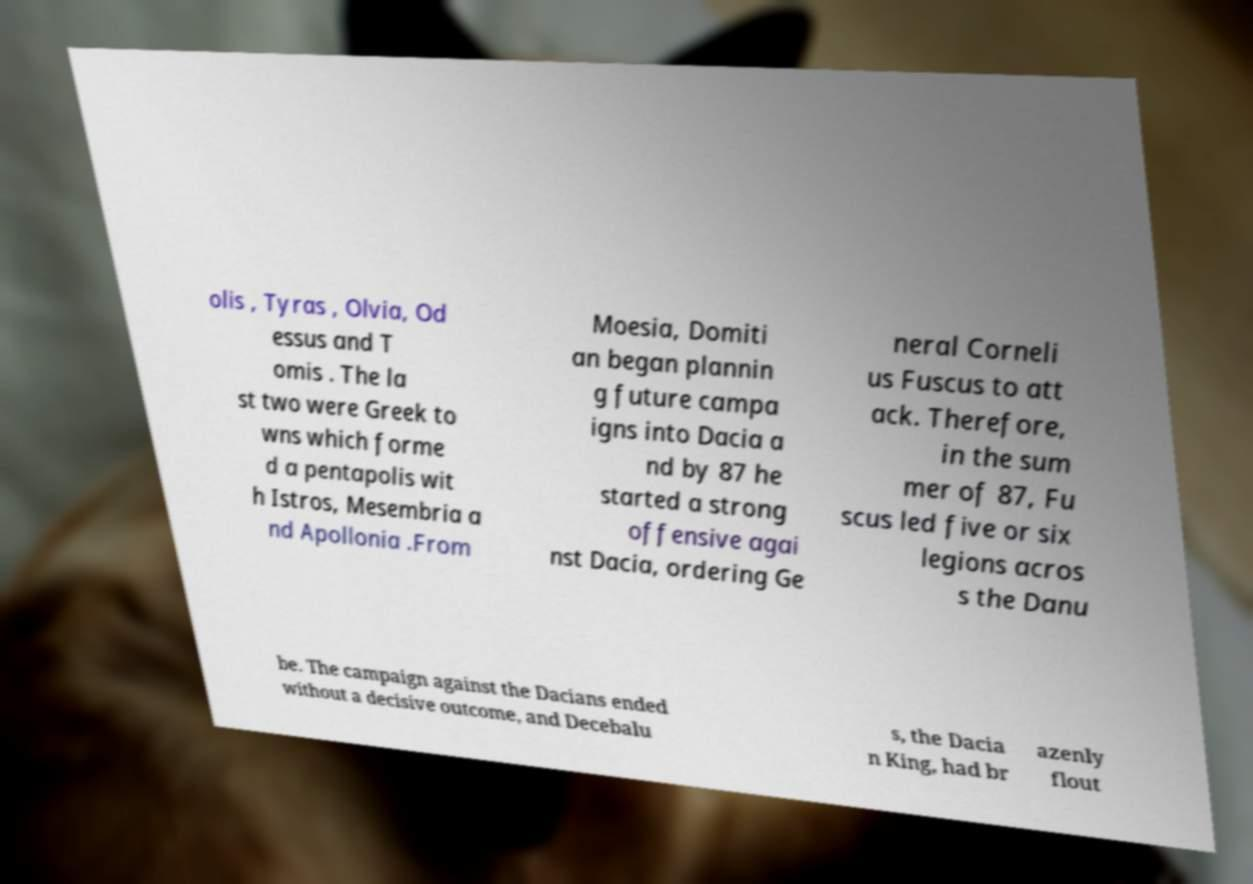There's text embedded in this image that I need extracted. Can you transcribe it verbatim? olis , Tyras , Olvia, Od essus and T omis . The la st two were Greek to wns which forme d a pentapolis wit h Istros, Mesembria a nd Apollonia .From Moesia, Domiti an began plannin g future campa igns into Dacia a nd by 87 he started a strong offensive agai nst Dacia, ordering Ge neral Corneli us Fuscus to att ack. Therefore, in the sum mer of 87, Fu scus led five or six legions acros s the Danu be. The campaign against the Dacians ended without a decisive outcome, and Decebalu s, the Dacia n King, had br azenly flout 